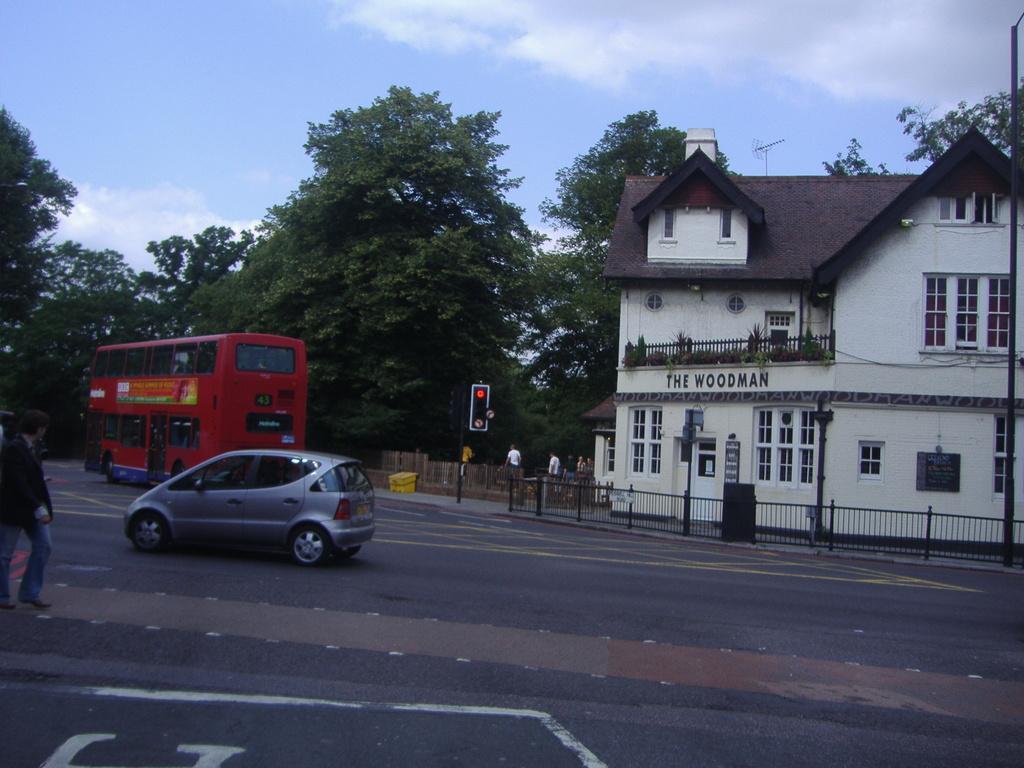Can you describe this image briefly? In this image I can see few vehicles on the road, in front I can see a person standing wearing black shirt, blue pant. Background I can see a traffic signal, a building in cream and brown color, trees in green color and the sky is in white and blue color. 